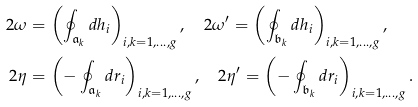<formula> <loc_0><loc_0><loc_500><loc_500>2 \omega & = \left ( \oint _ { \mathfrak { a } _ { k } } d h _ { i } \right ) _ { i , k = 1 , \dots , g } , \quad 2 \omega ^ { \prime } = \left ( \oint _ { \mathfrak { b } _ { k } } d h _ { i } \right ) _ { i , k = 1 , \dots , g } , \\ 2 \eta & = \left ( - \oint _ { \mathfrak { a } _ { k } } d r _ { i } \right ) _ { i , k = 1 , \dots , g } , \quad 2 \eta ^ { \prime } = \left ( - \oint _ { \mathfrak { b } _ { k } } d r _ { i } \right ) _ { i , k = 1 , \dots , g } .</formula> 